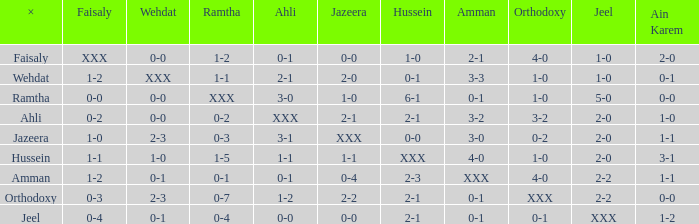What does ramtha represent if jeel has a 1-0 score and hussein also has a 1-0 score? 1-2. 